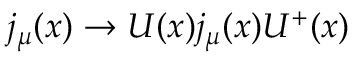<formula> <loc_0><loc_0><loc_500><loc_500>j _ { \mu } ( x ) \rightarrow U ( x ) j _ { \mu } ( x ) U ^ { + } ( x )</formula> 